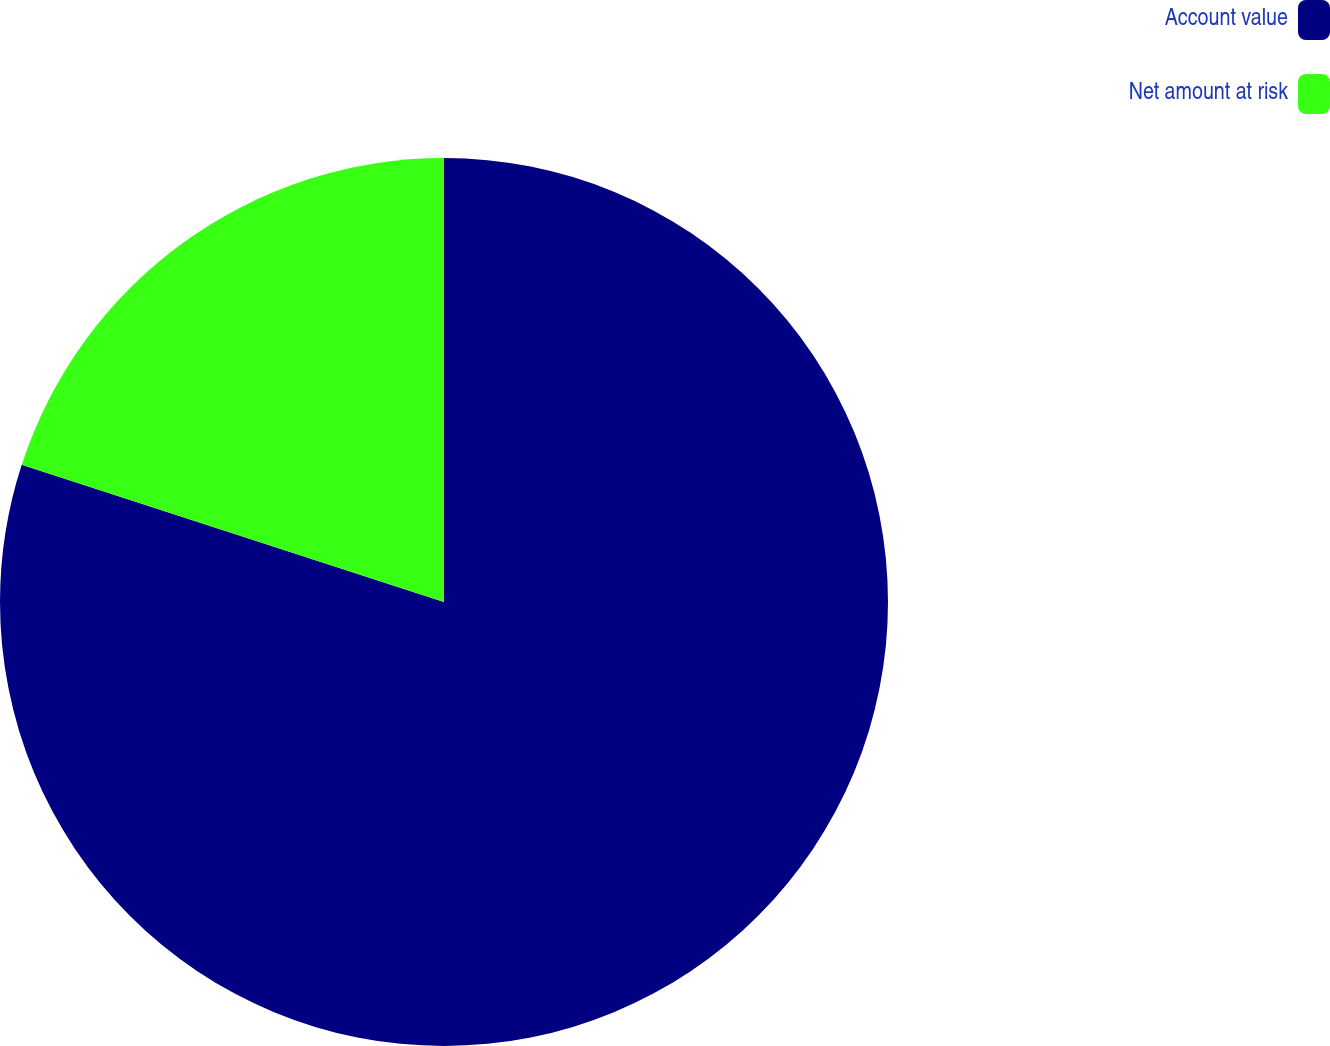Convert chart to OTSL. <chart><loc_0><loc_0><loc_500><loc_500><pie_chart><fcel>Account value<fcel>Net amount at risk<nl><fcel>80.0%<fcel>20.0%<nl></chart> 